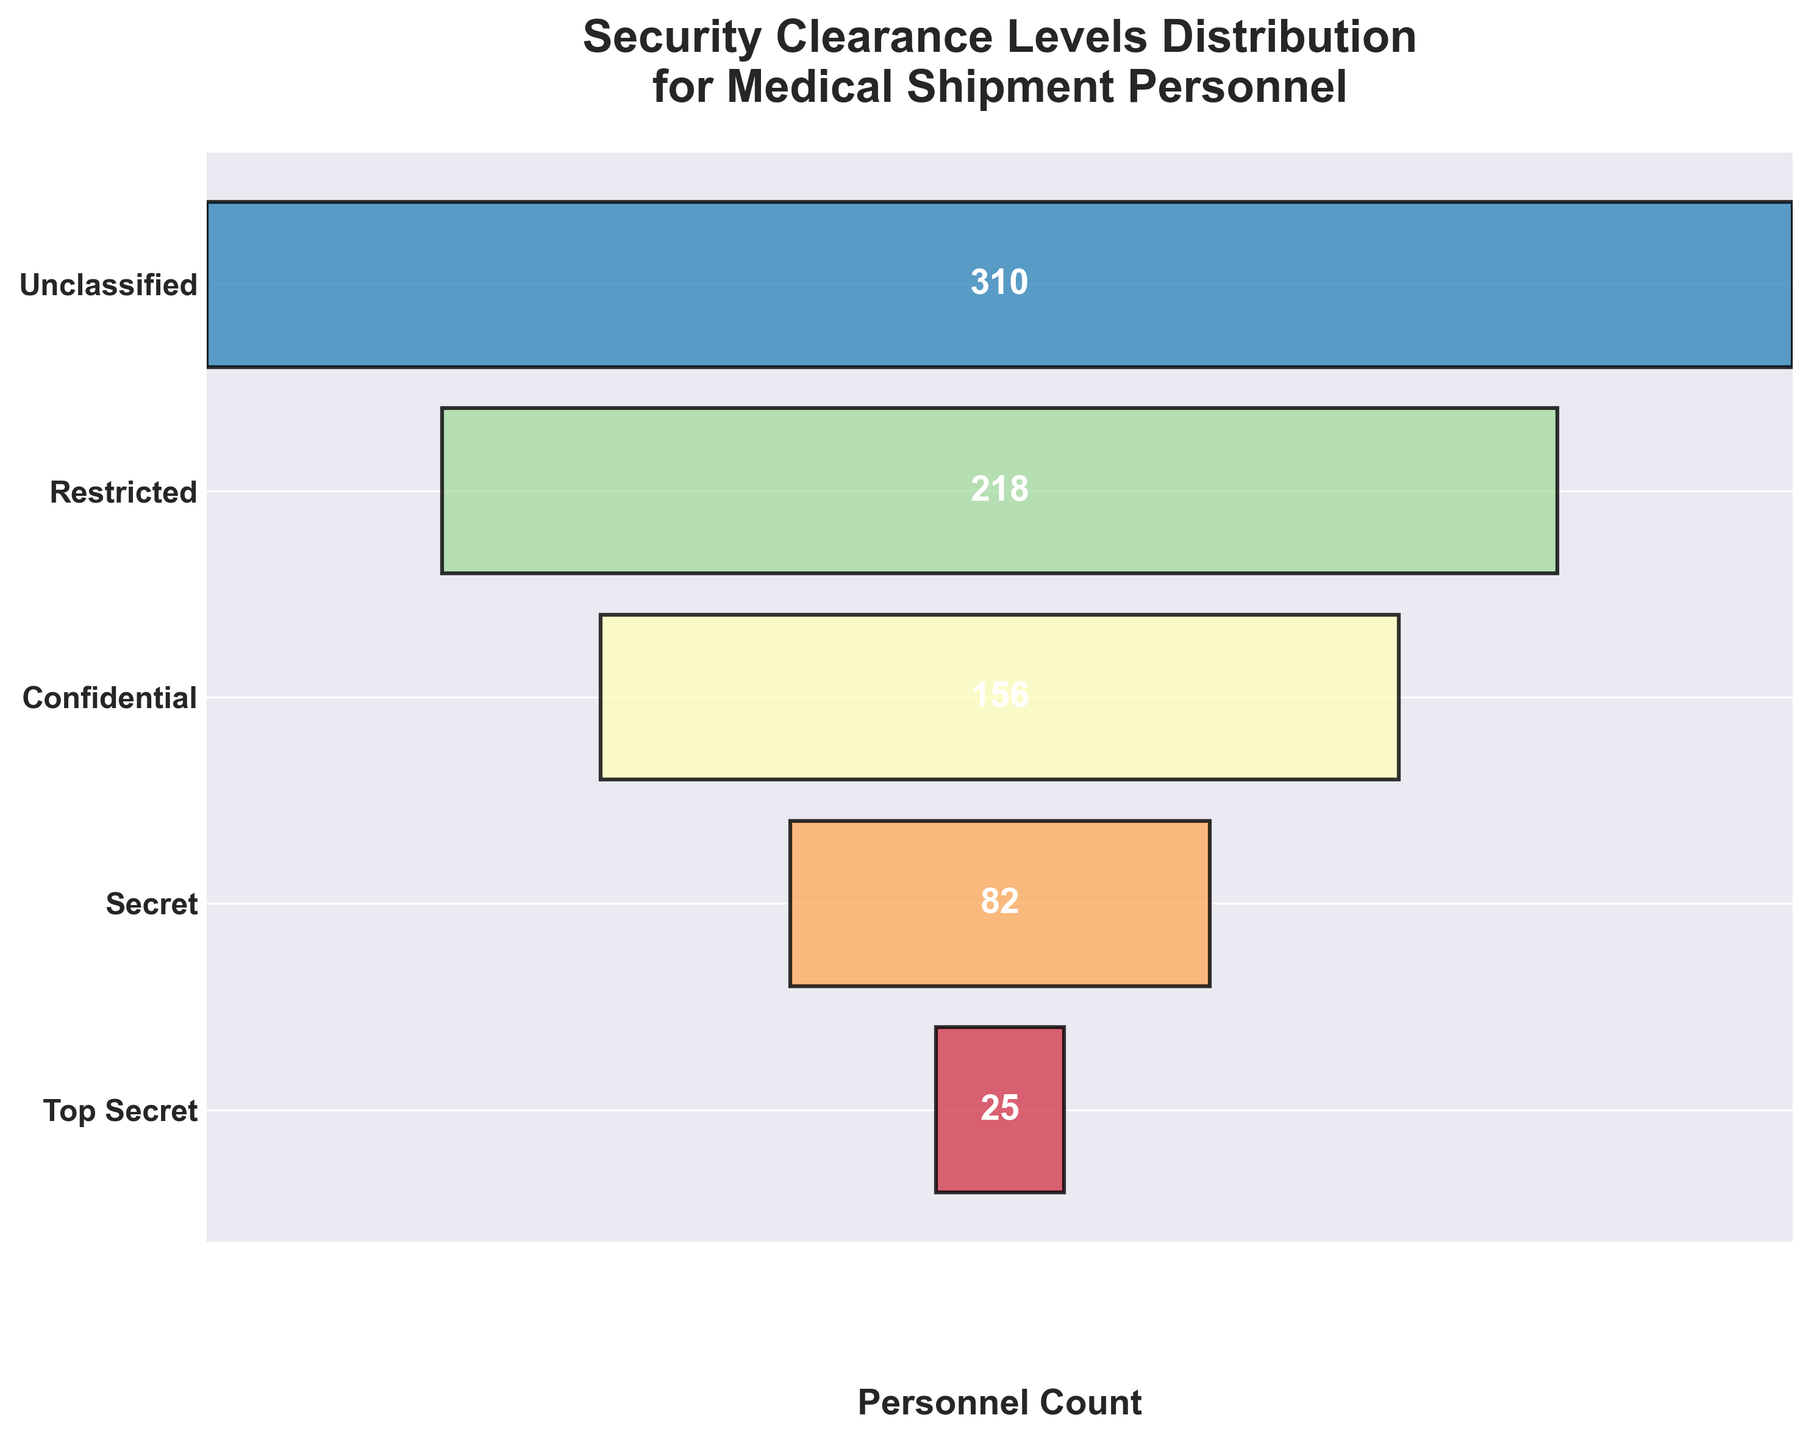What is the title of the funnel chart? The title is displayed at the top of the chart. It clearly indicates what the chart is representing.
Answer: Security Clearance Levels Distribution for Medical Shipment Personnel How many personnel have a "Secret" security clearance level? The count label for the "Secret" level is displayed in the middle of its corresponding bar.
Answer: 82 Which security clearance level has the highest number of personnel? By comparing the widths and count labels of all bars, the "Unclassified" level has the widest bar and the highest count label.
Answer: Unclassified How many total personnel are represented in the chart? Sum the counts across all security levels: 25 (Top Secret) + 82 (Secret) + 156 (Confidential) + 218 (Restricted) + 310 (Unclassified).
Answer: 791 What percentage of the total personnel have a "Confidential" security clearance level? First, find the total number of personnel, which is 791. Then, calculate the percentage: (156 / 791) * 100 ≈ 19.73%.
Answer: Approximately 19.73% Which security clearance level has fewer personnel than the "Confidential" level but more than the "Top Secret" level? Compare the counts: the "Secret" level has 82 personnel, which is fewer than 156 (Confidential) but more than 25 (Top Secret).
Answer: Secret What is the combined count for personnel with either "Top Secret" or "Secret" clearance? Add the counts for "Top Secret" (25) and "Secret" (82): 25 + 82 = 107.
Answer: 107 Among the listed security clearance levels, which one shows the largest drop in personnel count from the previous level? Compare the differences between subsequent levels: the largest drop in personnel count is from "Unclassified" (310) to "Restricted" (218), a drop of 92.
Answer: From Unclassified to Restricted How does the "Restricted" level personnel count compare to the "Unclassified" level? The "Restricted" level has 218 personnel, while "Unclassified" has 310. Comparing them shows that "Restricted" is 92 less than "Unclassified".
Answer: "Restricted" has 92 fewer personnel than "Unclassified" What's the median security clearance level based on personnel count? To find the median level, list all clearance levels in order with their counts: Top Secret (25), Secret (82), Confidential (156), Restricted (218), Unclassified (310). The median is the middle value, which is "Confidential" with 156 personnel.
Answer: Confidential 